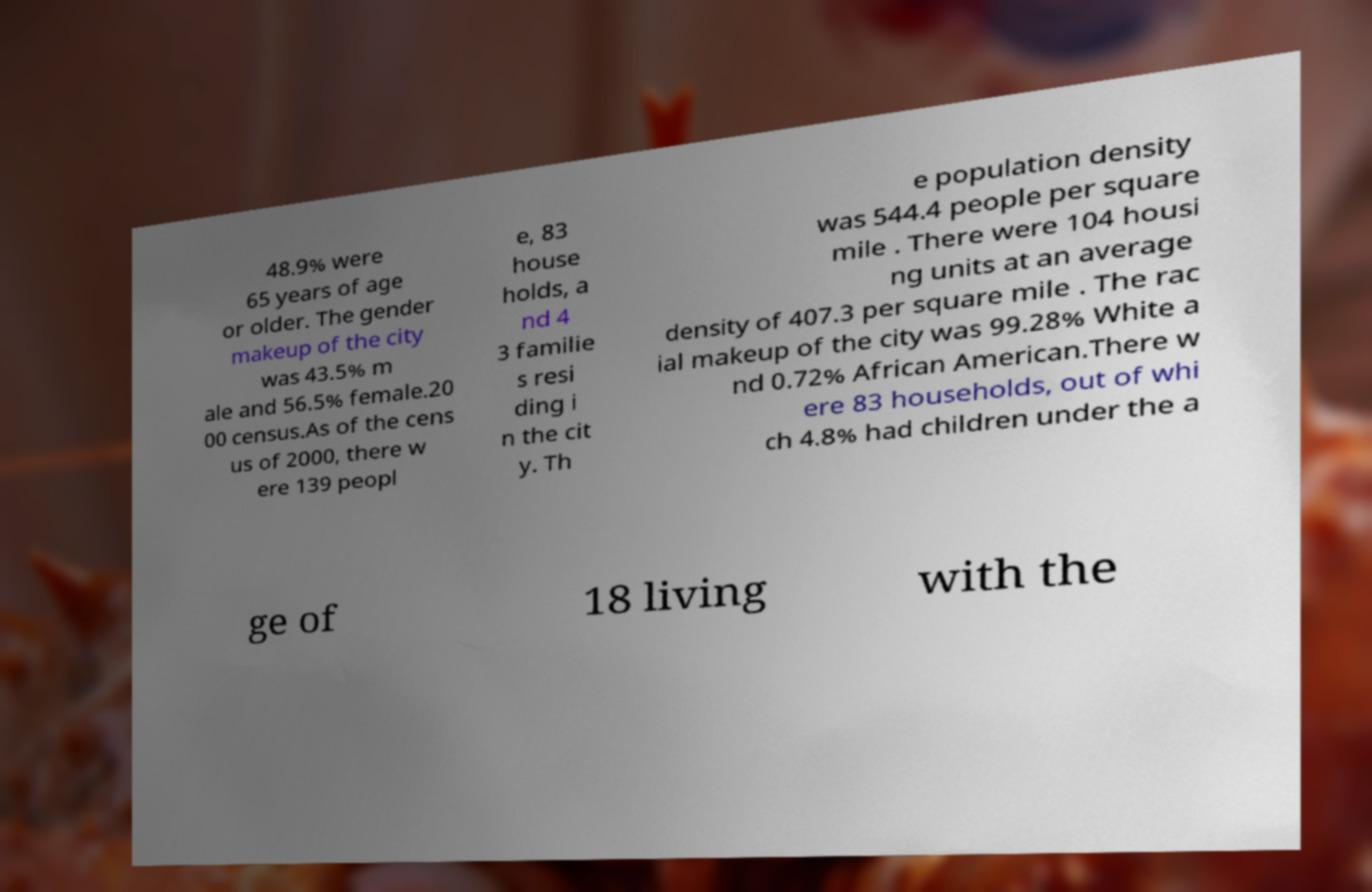For documentation purposes, I need the text within this image transcribed. Could you provide that? 48.9% were 65 years of age or older. The gender makeup of the city was 43.5% m ale and 56.5% female.20 00 census.As of the cens us of 2000, there w ere 139 peopl e, 83 house holds, a nd 4 3 familie s resi ding i n the cit y. Th e population density was 544.4 people per square mile . There were 104 housi ng units at an average density of 407.3 per square mile . The rac ial makeup of the city was 99.28% White a nd 0.72% African American.There w ere 83 households, out of whi ch 4.8% had children under the a ge of 18 living with the 